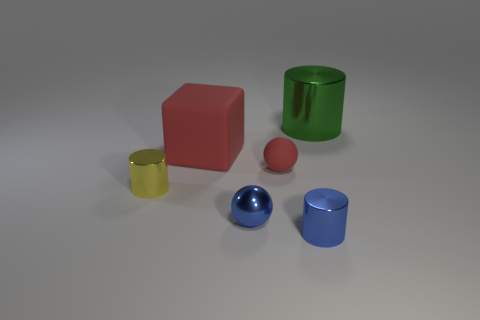Is the small cylinder on the left side of the small metallic sphere made of the same material as the big object to the right of the cube?
Provide a succinct answer. Yes. How big is the ball that is in front of the small red rubber ball behind the small cylinder to the right of the tiny yellow metallic cylinder?
Your answer should be compact. Small. What number of large green things are made of the same material as the large cylinder?
Make the answer very short. 0. Is the number of small green matte cylinders less than the number of small yellow metallic cylinders?
Provide a short and direct response. Yes. There is a blue shiny thing that is the same shape as the small yellow thing; what size is it?
Give a very brief answer. Small. Are the large thing that is in front of the big green cylinder and the big cylinder made of the same material?
Ensure brevity in your answer.  No. Does the tiny yellow metallic thing have the same shape as the green shiny thing?
Your answer should be very brief. Yes. How many things are either metal things on the left side of the large cylinder or small purple metallic cylinders?
Offer a terse response. 3. There is a green cylinder that is the same material as the blue sphere; what size is it?
Give a very brief answer. Large. What number of cylinders have the same color as the shiny ball?
Offer a terse response. 1. 